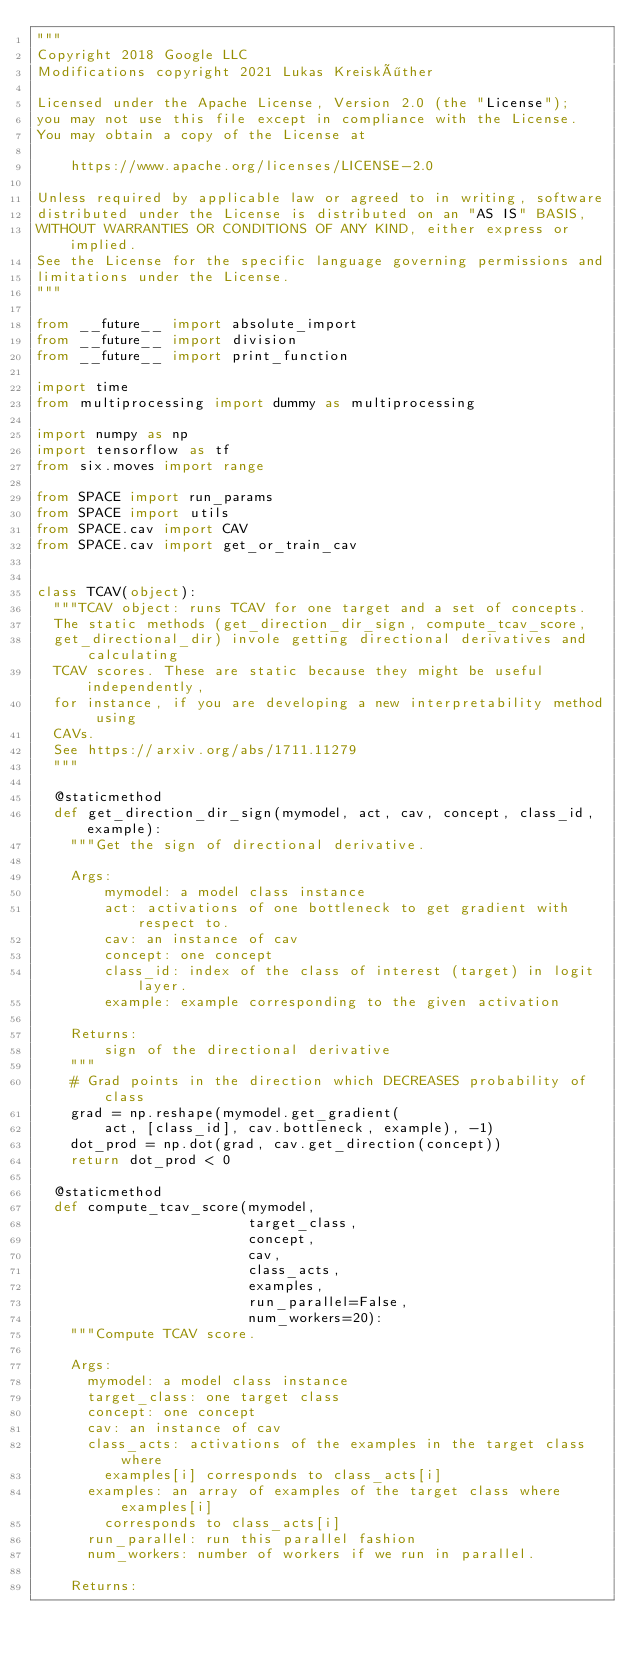Convert code to text. <code><loc_0><loc_0><loc_500><loc_500><_Python_>"""
Copyright 2018 Google LLC
Modifications copyright 2021 Lukas Kreisköther

Licensed under the Apache License, Version 2.0 (the "License");
you may not use this file except in compliance with the License.
You may obtain a copy of the License at

    https://www.apache.org/licenses/LICENSE-2.0

Unless required by applicable law or agreed to in writing, software
distributed under the License is distributed on an "AS IS" BASIS,
WITHOUT WARRANTIES OR CONDITIONS OF ANY KIND, either express or implied.
See the License for the specific language governing permissions and
limitations under the License.
"""

from __future__ import absolute_import
from __future__ import division
from __future__ import print_function

import time
from multiprocessing import dummy as multiprocessing

import numpy as np
import tensorflow as tf
from six.moves import range

from SPACE import run_params
from SPACE import utils
from SPACE.cav import CAV
from SPACE.cav import get_or_train_cav


class TCAV(object):
  """TCAV object: runs TCAV for one target and a set of concepts.
  The static methods (get_direction_dir_sign, compute_tcav_score,
  get_directional_dir) invole getting directional derivatives and calculating
  TCAV scores. These are static because they might be useful independently,
  for instance, if you are developing a new interpretability method using
  CAVs.
  See https://arxiv.org/abs/1711.11279
  """

  @staticmethod
  def get_direction_dir_sign(mymodel, act, cav, concept, class_id, example):
    """Get the sign of directional derivative.

    Args:
        mymodel: a model class instance
        act: activations of one bottleneck to get gradient with respect to.
        cav: an instance of cav
        concept: one concept
        class_id: index of the class of interest (target) in logit layer.
        example: example corresponding to the given activation

    Returns:
        sign of the directional derivative
    """
    # Grad points in the direction which DECREASES probability of class
    grad = np.reshape(mymodel.get_gradient(
        act, [class_id], cav.bottleneck, example), -1)
    dot_prod = np.dot(grad, cav.get_direction(concept))
    return dot_prod < 0

  @staticmethod
  def compute_tcav_score(mymodel,
                         target_class,
                         concept,
                         cav,
                         class_acts,
                         examples,
                         run_parallel=False,
                         num_workers=20):
    """Compute TCAV score.

    Args:
      mymodel: a model class instance
      target_class: one target class
      concept: one concept
      cav: an instance of cav
      class_acts: activations of the examples in the target class where
        examples[i] corresponds to class_acts[i]
      examples: an array of examples of the target class where examples[i]
        corresponds to class_acts[i]
      run_parallel: run this parallel fashion
      num_workers: number of workers if we run in parallel.

    Returns:</code> 